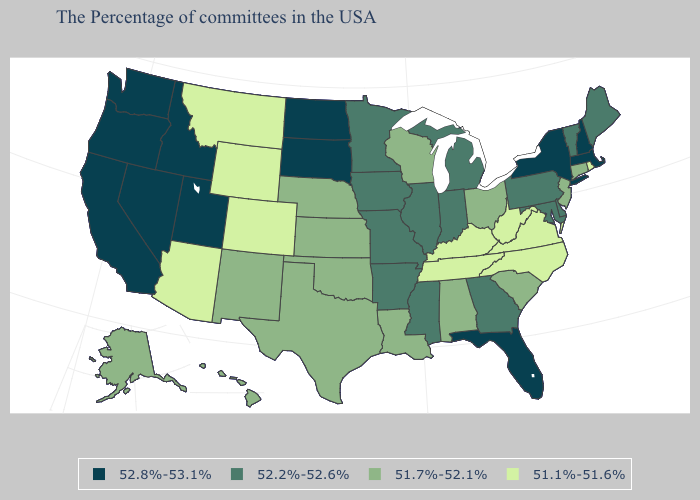Does Colorado have the same value as Utah?
Be succinct. No. What is the lowest value in the USA?
Keep it brief. 51.1%-51.6%. Among the states that border Oregon , which have the highest value?
Concise answer only. Idaho, Nevada, California, Washington. Does Delaware have the same value as Georgia?
Give a very brief answer. Yes. Name the states that have a value in the range 52.2%-52.6%?
Concise answer only. Maine, Vermont, Delaware, Maryland, Pennsylvania, Georgia, Michigan, Indiana, Illinois, Mississippi, Missouri, Arkansas, Minnesota, Iowa. Which states hav the highest value in the West?
Answer briefly. Utah, Idaho, Nevada, California, Washington, Oregon. Does Louisiana have the highest value in the South?
Concise answer only. No. What is the value of Rhode Island?
Keep it brief. 51.1%-51.6%. Does Mississippi have the lowest value in the South?
Quick response, please. No. What is the value of Montana?
Quick response, please. 51.1%-51.6%. Does New Jersey have a lower value than Iowa?
Concise answer only. Yes. What is the lowest value in the South?
Concise answer only. 51.1%-51.6%. What is the lowest value in the West?
Give a very brief answer. 51.1%-51.6%. Does Alabama have the same value as Wyoming?
Concise answer only. No. Name the states that have a value in the range 51.7%-52.1%?
Keep it brief. Connecticut, New Jersey, South Carolina, Ohio, Alabama, Wisconsin, Louisiana, Kansas, Nebraska, Oklahoma, Texas, New Mexico, Alaska, Hawaii. 